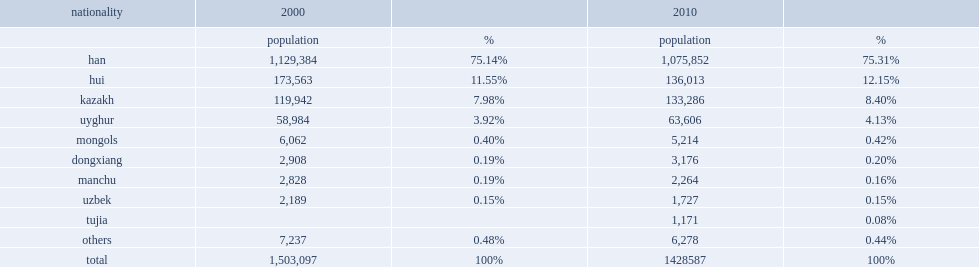According to the 2010 census, how many inhabitants did changji have a population of? 1428587. Would you mind parsing the complete table? {'header': ['nationality', '2000', '', '2010', ''], 'rows': [['', 'population', '%', 'population', '%'], ['han', '1,129,384', '75.14%', '1,075,852', '75.31%'], ['hui', '173,563', '11.55%', '136,013', '12.15%'], ['kazakh', '119,942', '7.98%', '133,286', '8.40%'], ['uyghur', '58,984', '3.92%', '63,606', '4.13%'], ['mongols', '6,062', '0.40%', '5,214', '0.42%'], ['dongxiang', '2,908', '0.19%', '3,176', '0.20%'], ['manchu', '2,828', '0.19%', '2,264', '0.16%'], ['uzbek', '2,189', '0.15%', '1,727', '0.15%'], ['tujia', '', '', '1,171', '0.08%'], ['others', '7,237', '0.48%', '6,278', '0.44%'], ['total', '1,503,097', '100%', '1428587', '100%']]} 